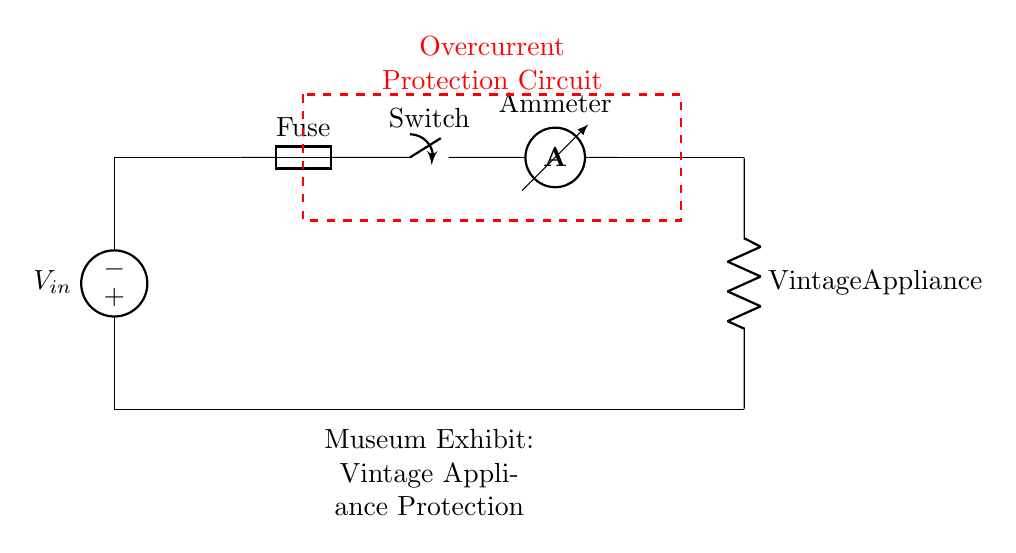What is the component used for overcurrent protection? The component labeled as "Fuse" within the circuit is responsible for overcurrent protection. It is positioned in series after the voltage source and before the switch, which indicates its role in interrupting the circuit in case of excess current.
Answer: Fuse What is the role of the switch in this circuit? The switch is used to control the flow of current to the vintage appliance. When the switch is closed, current can pass through to the appliance; when it is open, the current is stopped. The switch is positioned after the fuse and before the ammeter, indicating it is part of the control mechanism.
Answer: Control current flow How many components are involved in the overcurrent protection circuit? There are five primary components: a voltage source, a fuse, a switch, an ammeter, and the vintage appliance itself. Each component plays a unique role in the circuit, collectively forming the protection and measurement system.
Answer: Five What does the ammeter measure in this circuit? The ammeter is designed to measure the amount of current flowing through the circuit as it indicates the real-time current flow towards the vintage appliance. It is positioned after the fuse and switch, which ensures it measures current after the protective measures are in place.
Answer: Current flow What is the purpose of the vintage appliance in this circuit? The vintage appliance is the load of the circuit that consumes electrical energy. Its placement in the circuit indicates it is where the current is directed after passing through the protective measures and the switch, signifying its role as the end-use device.
Answer: Load What happens when the fuse blows in this circuit? When the fuse blows, it creates an open circuit that stops the current flow to the vintage appliance, thereby protecting it from overcurrent damage. The fuse is specifically designed to melt and interrupt the circuit when the current exceeds its rated value, ensuring safety for the appliance.
Answer: Stops current flow What is indicated by the dashed rectangle around the components? The dashed rectangle signifies the overall boundary of the overcurrent protection circuit, highlighting the components involved in protecting the vintage appliance from excessive current. This visual cue emphasizes what elements contribute to the circuit's protective measures.
Answer: Overcurrent protection circuit 